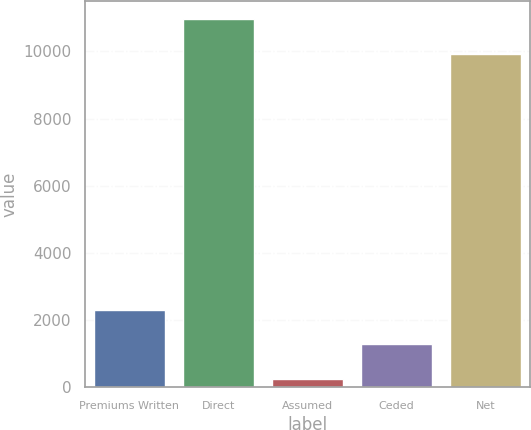Convert chart to OTSL. <chart><loc_0><loc_0><loc_500><loc_500><bar_chart><fcel>Premiums Written<fcel>Direct<fcel>Assumed<fcel>Ceded<fcel>Net<nl><fcel>2310.4<fcel>10960.7<fcel>247<fcel>1278.7<fcel>9929<nl></chart> 